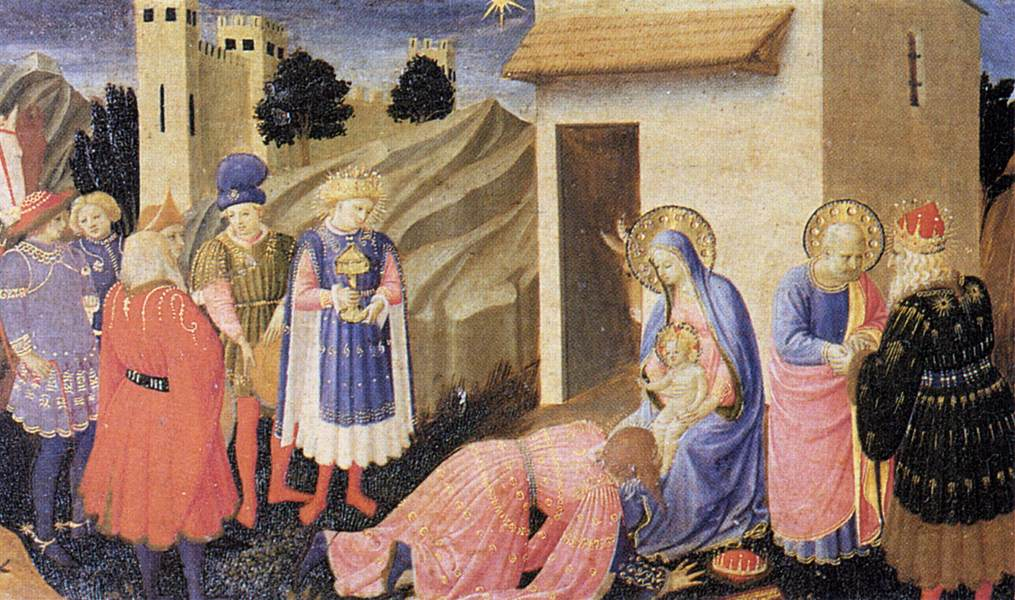Can you describe the attire of the figures in the scene? Certainly! The figures in the scene are adorned in rich, colorful robes which are characteristic of Gothic art. The three Magi are particularly prominent, dressed in magnificently detailed robes. One of them wears a blue robe with white and gold accents, another is in a red robe with a golden crown, and the third Magus has a robe in gold, enhancing the regal atmosphere. The Virgin Mary is depicted in a vivid blue robe, symbolizing her purity and divinity, while the infant Jesus is dressed in a simple yet elegant garment. The other figures nearby are also clad in robes of red, gold, and blue, each garment finely detailed with intricate patterns and embroidery, suggesting their high social status and the importance of this momentous event. 